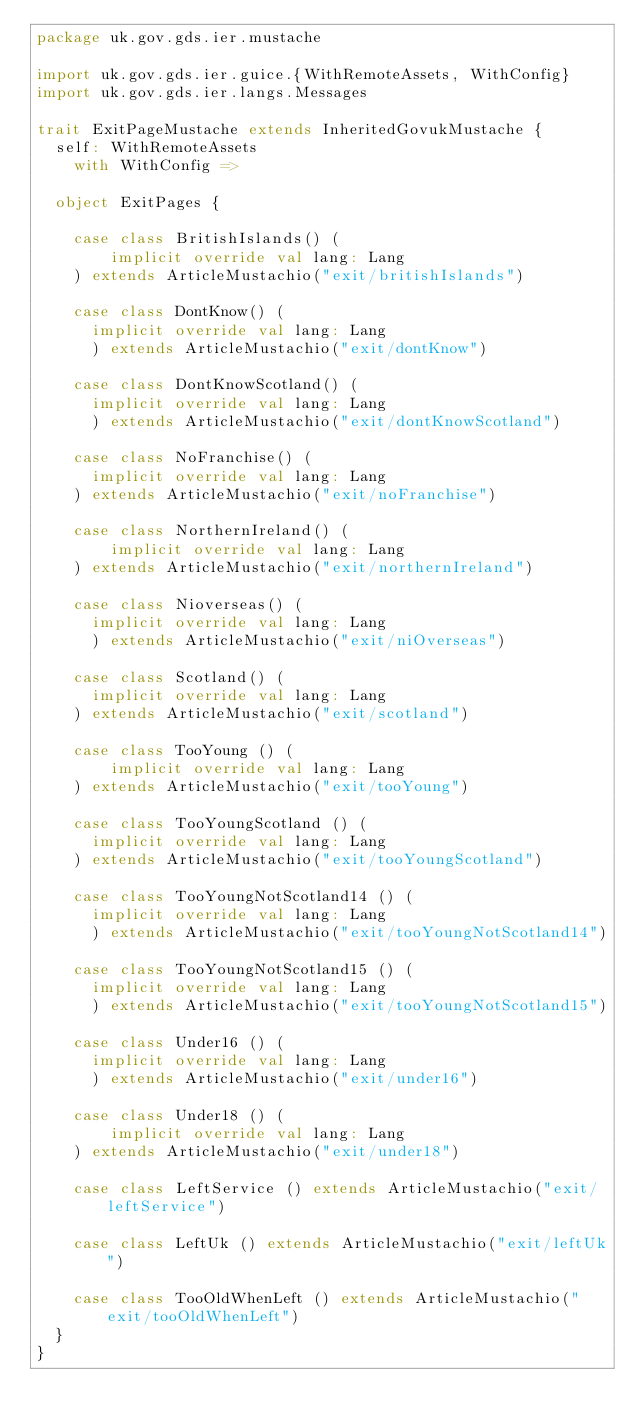<code> <loc_0><loc_0><loc_500><loc_500><_Scala_>package uk.gov.gds.ier.mustache

import uk.gov.gds.ier.guice.{WithRemoteAssets, WithConfig}
import uk.gov.gds.ier.langs.Messages

trait ExitPageMustache extends InheritedGovukMustache {
  self: WithRemoteAssets
    with WithConfig =>

  object ExitPages {

    case class BritishIslands() (
        implicit override val lang: Lang
    ) extends ArticleMustachio("exit/britishIslands")

    case class DontKnow() (
      implicit override val lang: Lang
      ) extends ArticleMustachio("exit/dontKnow")

    case class DontKnowScotland() (
      implicit override val lang: Lang
      ) extends ArticleMustachio("exit/dontKnowScotland")

    case class NoFranchise() (
      implicit override val lang: Lang
    ) extends ArticleMustachio("exit/noFranchise")

    case class NorthernIreland() (
        implicit override val lang: Lang
    ) extends ArticleMustachio("exit/northernIreland")

    case class Nioverseas() (
      implicit override val lang: Lang
      ) extends ArticleMustachio("exit/niOverseas")

    case class Scotland() (
      implicit override val lang: Lang
    ) extends ArticleMustachio("exit/scotland")

    case class TooYoung () (
        implicit override val lang: Lang
    ) extends ArticleMustachio("exit/tooYoung")

    case class TooYoungScotland () (
      implicit override val lang: Lang
    ) extends ArticleMustachio("exit/tooYoungScotland")

    case class TooYoungNotScotland14 () (
      implicit override val lang: Lang
      ) extends ArticleMustachio("exit/tooYoungNotScotland14")

    case class TooYoungNotScotland15 () (
      implicit override val lang: Lang
      ) extends ArticleMustachio("exit/tooYoungNotScotland15")

    case class Under16 () (
      implicit override val lang: Lang
      ) extends ArticleMustachio("exit/under16")

    case class Under18 () (
        implicit override val lang: Lang
    ) extends ArticleMustachio("exit/under18")

    case class LeftService () extends ArticleMustachio("exit/leftService")

    case class LeftUk () extends ArticleMustachio("exit/leftUk")

    case class TooOldWhenLeft () extends ArticleMustachio("exit/tooOldWhenLeft")
  }
}
</code> 